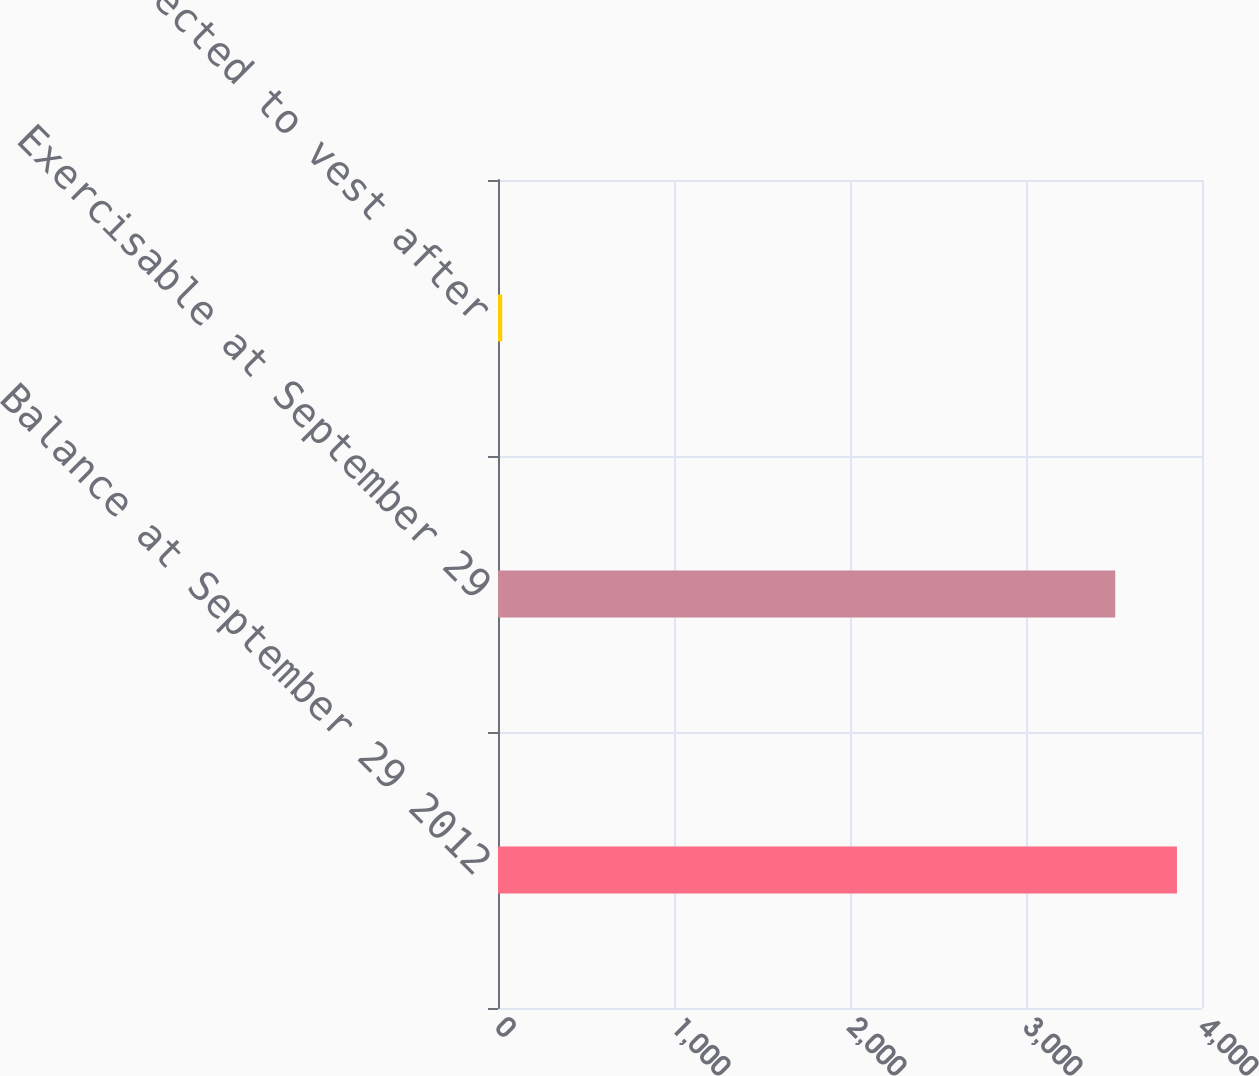Convert chart. <chart><loc_0><loc_0><loc_500><loc_500><bar_chart><fcel>Balance at September 29 2012<fcel>Exercisable at September 29<fcel>Expected to vest after<nl><fcel>3857.7<fcel>3507<fcel>24<nl></chart> 